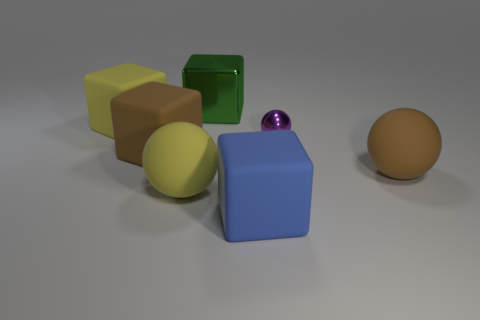Add 3 large green metal blocks. How many objects exist? 10 Subtract all yellow matte blocks. How many blocks are left? 3 Subtract all balls. How many objects are left? 4 Add 4 big spheres. How many big spheres are left? 6 Add 2 large green objects. How many large green objects exist? 3 Subtract all brown blocks. How many blocks are left? 3 Subtract 1 green cubes. How many objects are left? 6 Subtract 2 spheres. How many spheres are left? 1 Subtract all cyan spheres. Subtract all brown cubes. How many spheres are left? 3 Subtract all green blocks. How many yellow spheres are left? 1 